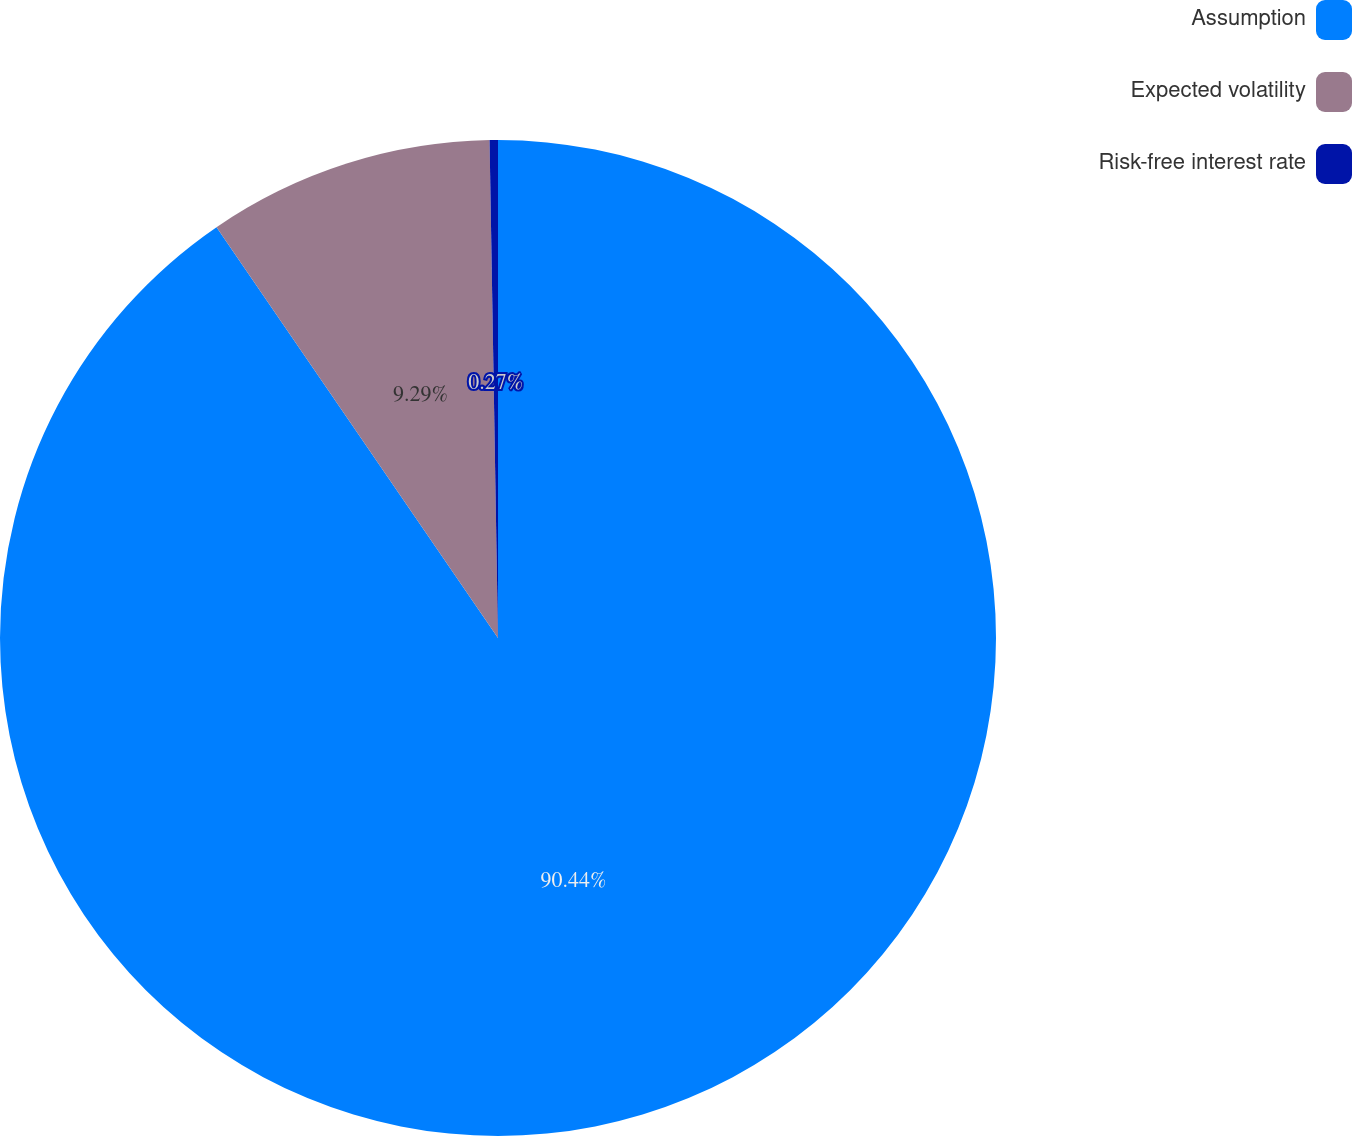Convert chart to OTSL. <chart><loc_0><loc_0><loc_500><loc_500><pie_chart><fcel>Assumption<fcel>Expected volatility<fcel>Risk-free interest rate<nl><fcel>90.44%<fcel>9.29%<fcel>0.27%<nl></chart> 